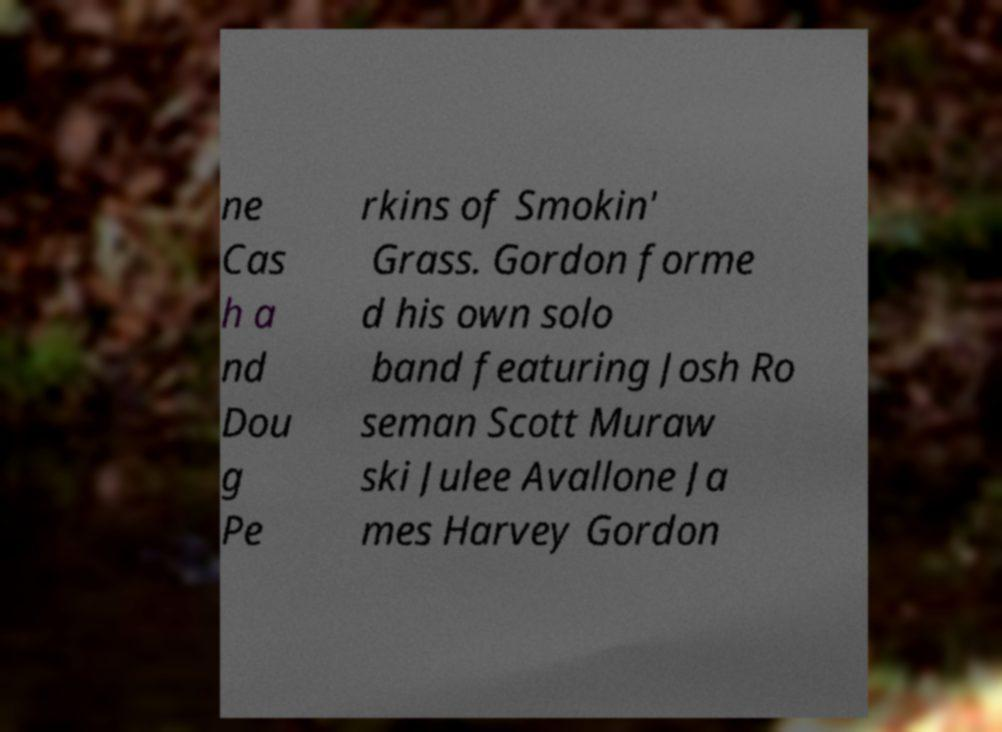Please read and relay the text visible in this image. What does it say? ne Cas h a nd Dou g Pe rkins of Smokin' Grass. Gordon forme d his own solo band featuring Josh Ro seman Scott Muraw ski Julee Avallone Ja mes Harvey Gordon 